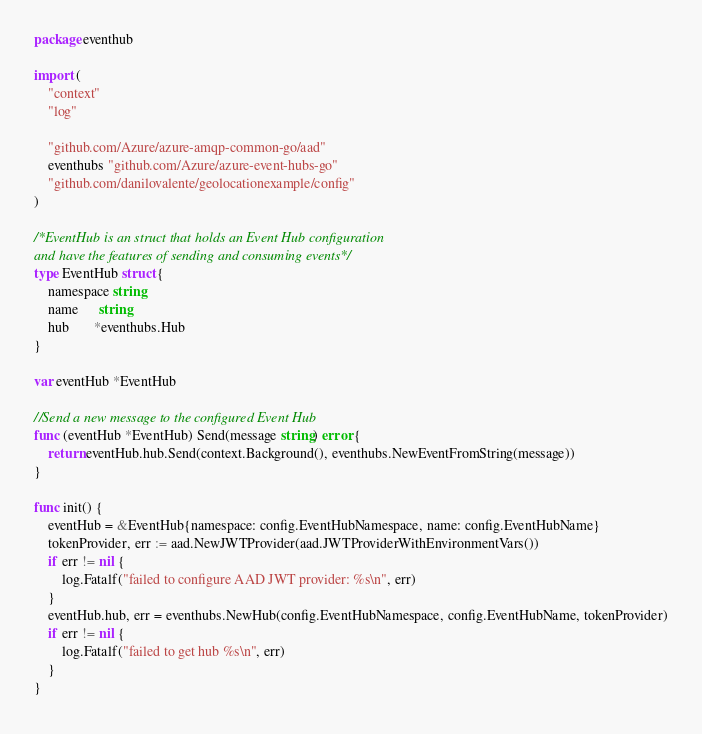<code> <loc_0><loc_0><loc_500><loc_500><_Go_>package eventhub

import (
	"context"
	"log"

	"github.com/Azure/azure-amqp-common-go/aad"
	eventhubs "github.com/Azure/azure-event-hubs-go"
	"github.com/danilovalente/geolocationexample/config"
)

/*EventHub is an struct that holds an Event Hub configuration
and have the features of sending and consuming events*/
type EventHub struct {
	namespace string
	name      string
	hub       *eventhubs.Hub
}

var eventHub *EventHub

//Send a new message to the configured Event Hub
func (eventHub *EventHub) Send(message string) error {
	return eventHub.hub.Send(context.Background(), eventhubs.NewEventFromString(message))
}

func init() {
	eventHub = &EventHub{namespace: config.EventHubNamespace, name: config.EventHubName}
	tokenProvider, err := aad.NewJWTProvider(aad.JWTProviderWithEnvironmentVars())
	if err != nil {
		log.Fatalf("failed to configure AAD JWT provider: %s\n", err)
	}
	eventHub.hub, err = eventhubs.NewHub(config.EventHubNamespace, config.EventHubName, tokenProvider)
	if err != nil {
		log.Fatalf("failed to get hub %s\n", err)
	}
}
</code> 